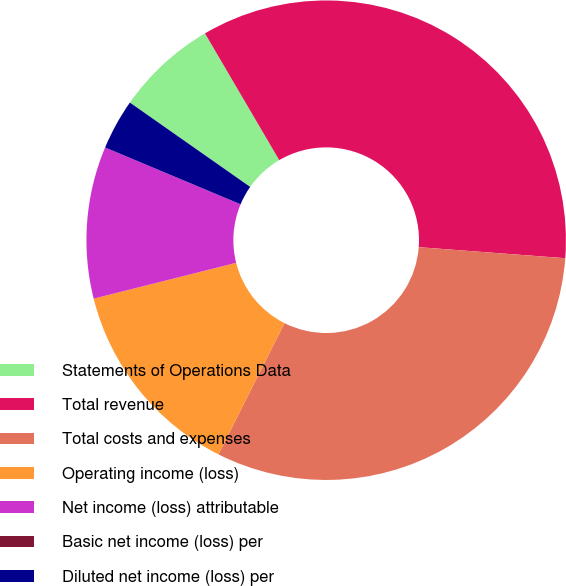Convert chart to OTSL. <chart><loc_0><loc_0><loc_500><loc_500><pie_chart><fcel>Statements of Operations Data<fcel>Total revenue<fcel>Total costs and expenses<fcel>Operating income (loss)<fcel>Net income (loss) attributable<fcel>Basic net income (loss) per<fcel>Diluted net income (loss) per<nl><fcel>6.83%<fcel>34.63%<fcel>31.22%<fcel>13.66%<fcel>10.24%<fcel>0.0%<fcel>3.41%<nl></chart> 